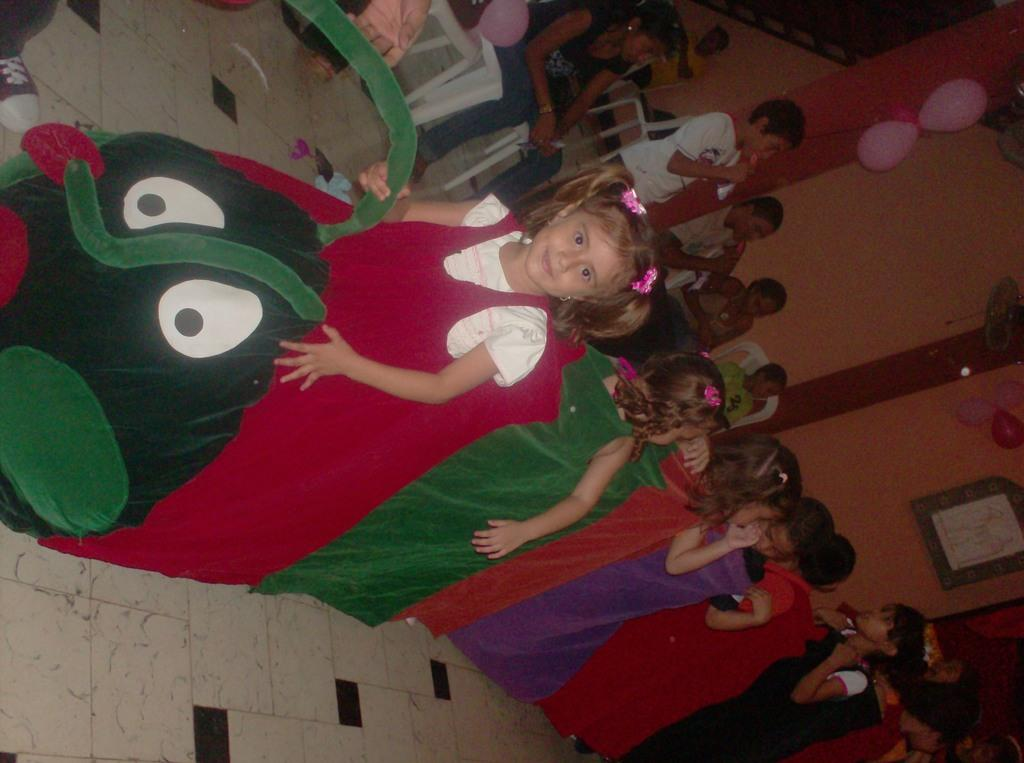What are the kids in the foreground of the picture doing? The kids in the foreground of the picture are playing. What can be seen in the background of the picture? There are chairs, people, and kids in the background of the picture. What is located on the right side of the picture? There are balloons and a pillar on the right side of the picture. What type of structure is present on the right side of the picture? There is a wall on the right side of the picture. What type of fear can be seen on the faces of the kids in the picture? There is no indication of fear on the faces of the kids in the picture; they are playing. How many times has the sponge been twisted in the image? There is no sponge present in the image. 